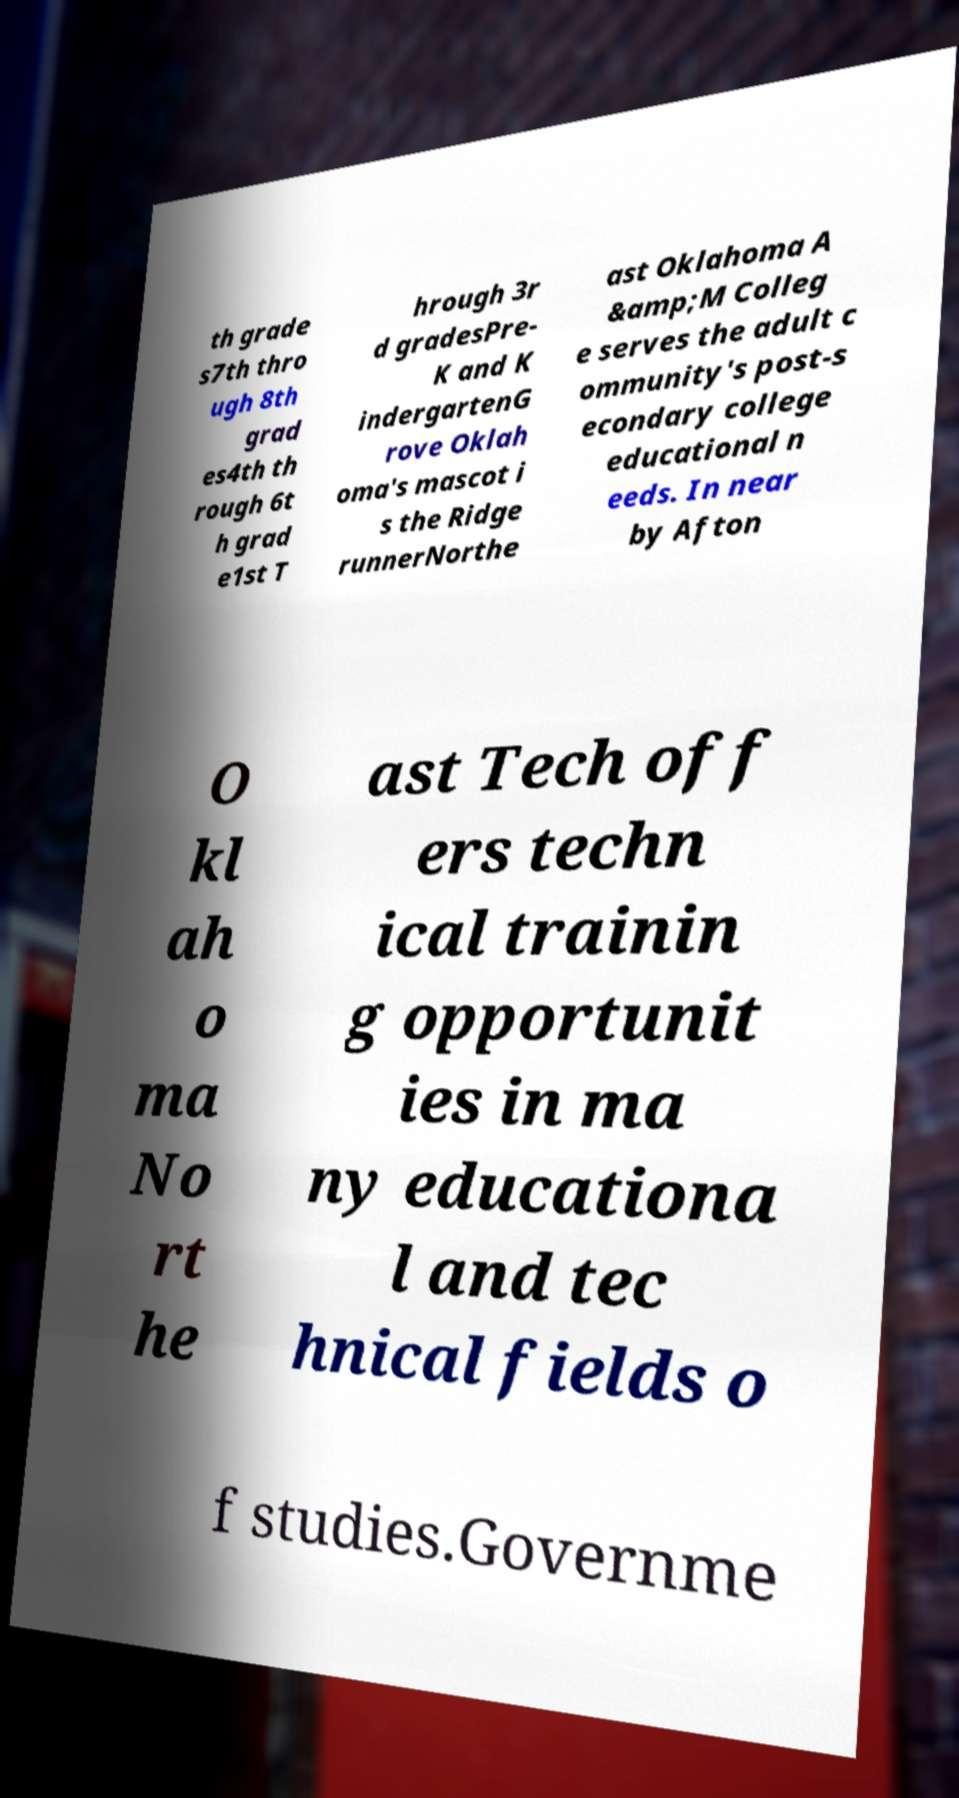I need the written content from this picture converted into text. Can you do that? th grade s7th thro ugh 8th grad es4th th rough 6t h grad e1st T hrough 3r d gradesPre- K and K indergartenG rove Oklah oma's mascot i s the Ridge runnerNorthe ast Oklahoma A &amp;M Colleg e serves the adult c ommunity's post-s econdary college educational n eeds. In near by Afton O kl ah o ma No rt he ast Tech off ers techn ical trainin g opportunit ies in ma ny educationa l and tec hnical fields o f studies.Governme 